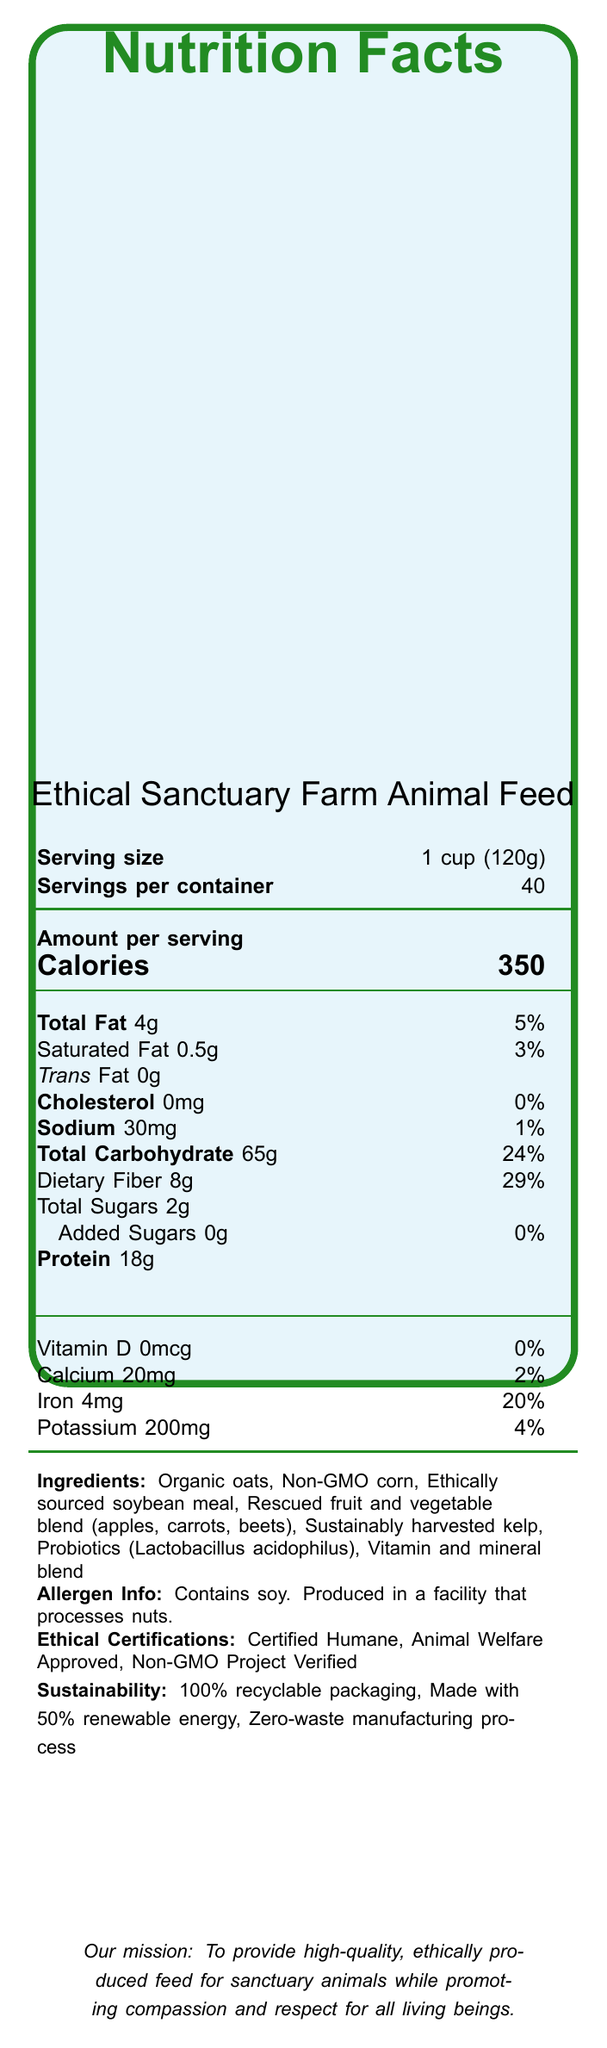what is the serving size? The serving size is explicitly listed as "1 cup (120g)" on the document.
Answer: 1 cup (120g) how many servings are contained in one package? The document states that there are 40 servings per container.
Answer: 40 how many calories are there per serving? The number of calories per serving is listed as 350.
Answer: 350 which ingredient is listed first in the ingredient list? The first ingredient listed is "Organic oats".
Answer: Organic oats does the product contain any cholesterol? The document lists "Cholesterol: 0mg (0%)", indicating that there is no cholesterol in the product.
Answer: No what certifications does this product have? A. Certified Humane B. Animal Welfare Approved C. USDA Organic D. Non-GMO Project Verified The document lists the certifications as "Certified Humane," "Animal Welfare Approved," and "Non-GMO Project Verified".
Answer: C what is the total amount of dietary fiber per serving, and what is its daily value percentage? The document lists "Dietary Fiber: 8g (29%)".
Answer: 8g, 29% which ingredient is listed as a source of probiotics? The document lists "Probiotics (Lactobacillus acidophilus)" among its ingredients.
Answer: Lactobacillus acidophilus does the product contain any added sugars? The document states "Added Sugars: 0g (0%)", indicating there are no added sugars.
Answer: No is the packaging of this product recyclable? The document mentions "100% recyclable packaging" under sustainability features.
Answer: Yes what ethical certifications does the product have? The document lists these three certifications under the ethical certifications section.
Answer: Certified Humane, Animal Welfare Approved, Non-GMO Project Verified how much protein is in one serving of this feed? The amount of protein per serving is 18g as listed in the document.
Answer: 18g how much sodium is in each serving? The document specifies that there are 30mg of sodium per serving.
Answer: 30mg is this product gluten-free? The document does not provide any specific information about gluten or whether the product is gluten-free.
Answer: Not enough information does the product contain any soy? The allergen info section states "Contains soy."
Answer: Yes summarize the main idea of the document. The document contains comprehensive nutritional information about the farm animal feed, outlines its ethical and sustainable qualities, and emphasizes its suitability for sanctuary animals.
Answer: The document provides detailed nutritional information for Ethical Sanctuary Farm Animal Feed, including serving size, macronutrient content, vitamins, and minerals. It emphasizes the ethical sourcing and sustainability of the ingredients, listing certifications like Certified Humane and Animal Welfare Approved. The product is designed to meet the nutritional needs of rescued farm animals without compromising ethical standards, and is made with sustainable practices. 